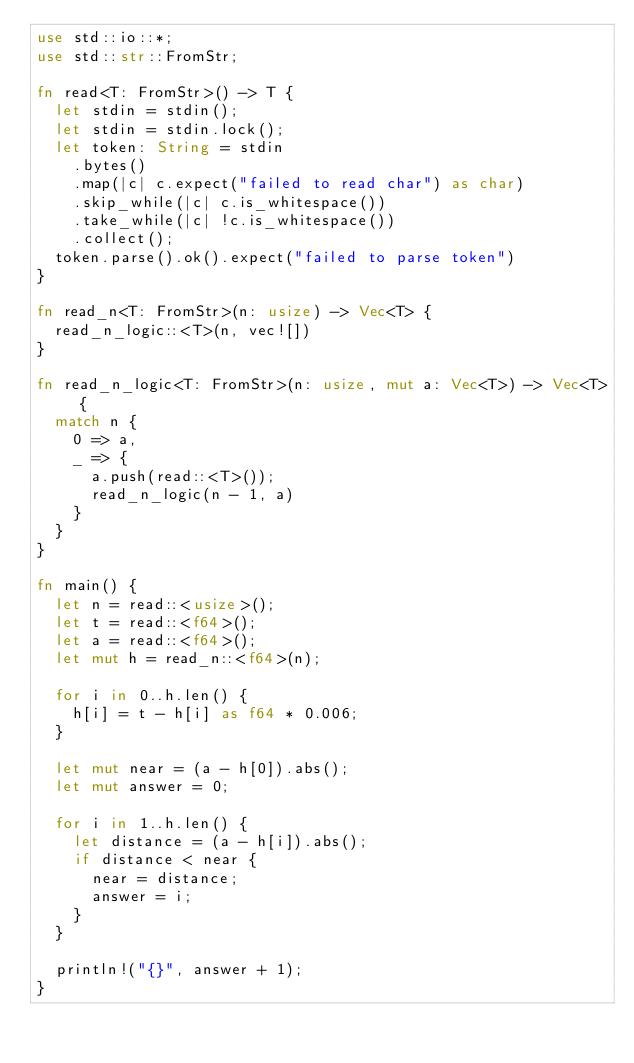Convert code to text. <code><loc_0><loc_0><loc_500><loc_500><_Rust_>use std::io::*;
use std::str::FromStr;

fn read<T: FromStr>() -> T {
  let stdin = stdin();
  let stdin = stdin.lock();
  let token: String = stdin
    .bytes()
    .map(|c| c.expect("failed to read char") as char)
    .skip_while(|c| c.is_whitespace())
    .take_while(|c| !c.is_whitespace())
    .collect();
  token.parse().ok().expect("failed to parse token")
}

fn read_n<T: FromStr>(n: usize) -> Vec<T> {
  read_n_logic::<T>(n, vec![])
}

fn read_n_logic<T: FromStr>(n: usize, mut a: Vec<T>) -> Vec<T> {
  match n {
    0 => a,
    _ => {
      a.push(read::<T>());
      read_n_logic(n - 1, a)
    }
  }
}

fn main() {
  let n = read::<usize>();
  let t = read::<f64>();
  let a = read::<f64>();
  let mut h = read_n::<f64>(n);

  for i in 0..h.len() {
    h[i] = t - h[i] as f64 * 0.006;
  }

  let mut near = (a - h[0]).abs();
  let mut answer = 0;

  for i in 1..h.len() {
    let distance = (a - h[i]).abs();
    if distance < near {
      near = distance;
      answer = i;
    }
  }

  println!("{}", answer + 1);
}
</code> 